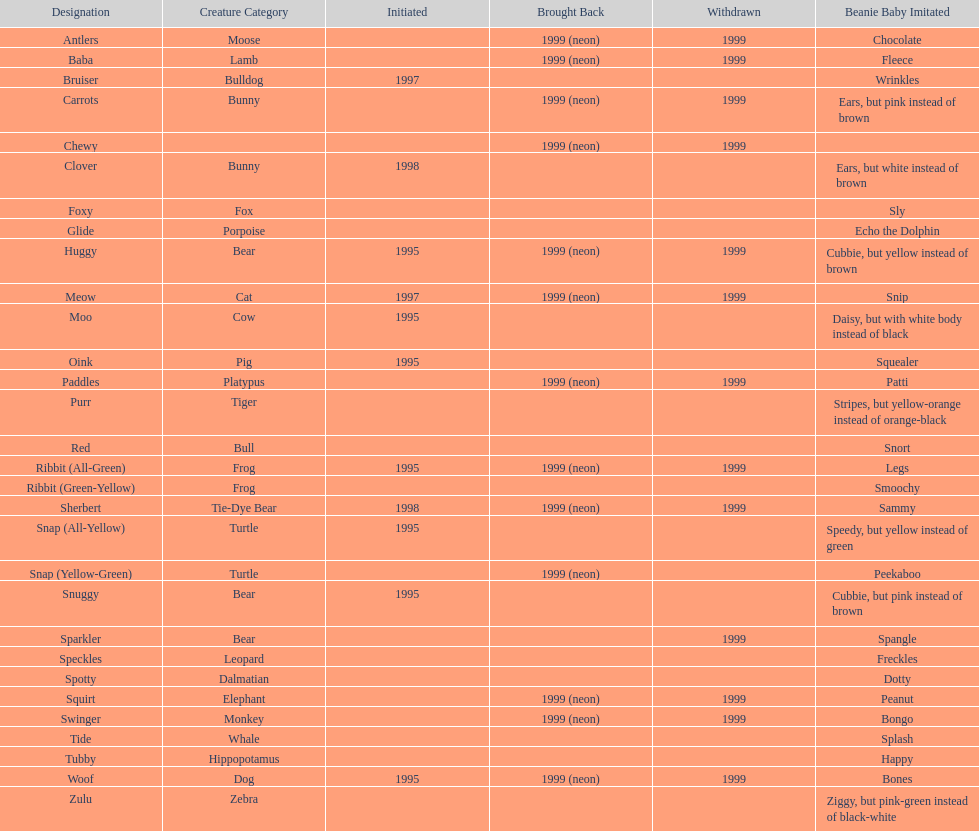Could you parse the entire table? {'header': ['Designation', 'Creature Category', 'Initiated', 'Brought Back', 'Withdrawn', 'Beanie Baby Imitated'], 'rows': [['Antlers', 'Moose', '', '1999 (neon)', '1999', 'Chocolate'], ['Baba', 'Lamb', '', '1999 (neon)', '1999', 'Fleece'], ['Bruiser', 'Bulldog', '1997', '', '', 'Wrinkles'], ['Carrots', 'Bunny', '', '1999 (neon)', '1999', 'Ears, but pink instead of brown'], ['Chewy', '', '', '1999 (neon)', '1999', ''], ['Clover', 'Bunny', '1998', '', '', 'Ears, but white instead of brown'], ['Foxy', 'Fox', '', '', '', 'Sly'], ['Glide', 'Porpoise', '', '', '', 'Echo the Dolphin'], ['Huggy', 'Bear', '1995', '1999 (neon)', '1999', 'Cubbie, but yellow instead of brown'], ['Meow', 'Cat', '1997', '1999 (neon)', '1999', 'Snip'], ['Moo', 'Cow', '1995', '', '', 'Daisy, but with white body instead of black'], ['Oink', 'Pig', '1995', '', '', 'Squealer'], ['Paddles', 'Platypus', '', '1999 (neon)', '1999', 'Patti'], ['Purr', 'Tiger', '', '', '', 'Stripes, but yellow-orange instead of orange-black'], ['Red', 'Bull', '', '', '', 'Snort'], ['Ribbit (All-Green)', 'Frog', '1995', '1999 (neon)', '1999', 'Legs'], ['Ribbit (Green-Yellow)', 'Frog', '', '', '', 'Smoochy'], ['Sherbert', 'Tie-Dye Bear', '1998', '1999 (neon)', '1999', 'Sammy'], ['Snap (All-Yellow)', 'Turtle', '1995', '', '', 'Speedy, but yellow instead of green'], ['Snap (Yellow-Green)', 'Turtle', '', '1999 (neon)', '', 'Peekaboo'], ['Snuggy', 'Bear', '1995', '', '', 'Cubbie, but pink instead of brown'], ['Sparkler', 'Bear', '', '', '1999', 'Spangle'], ['Speckles', 'Leopard', '', '', '', 'Freckles'], ['Spotty', 'Dalmatian', '', '', '', 'Dotty'], ['Squirt', 'Elephant', '', '1999 (neon)', '1999', 'Peanut'], ['Swinger', 'Monkey', '', '1999 (neon)', '1999', 'Bongo'], ['Tide', 'Whale', '', '', '', 'Splash'], ['Tubby', 'Hippopotamus', '', '', '', 'Happy'], ['Woof', 'Dog', '1995', '1999 (neon)', '1999', 'Bones'], ['Zulu', 'Zebra', '', '', '', 'Ziggy, but pink-green instead of black-white']]} Which is the only pillow pal without a listed animal type? Chewy. 